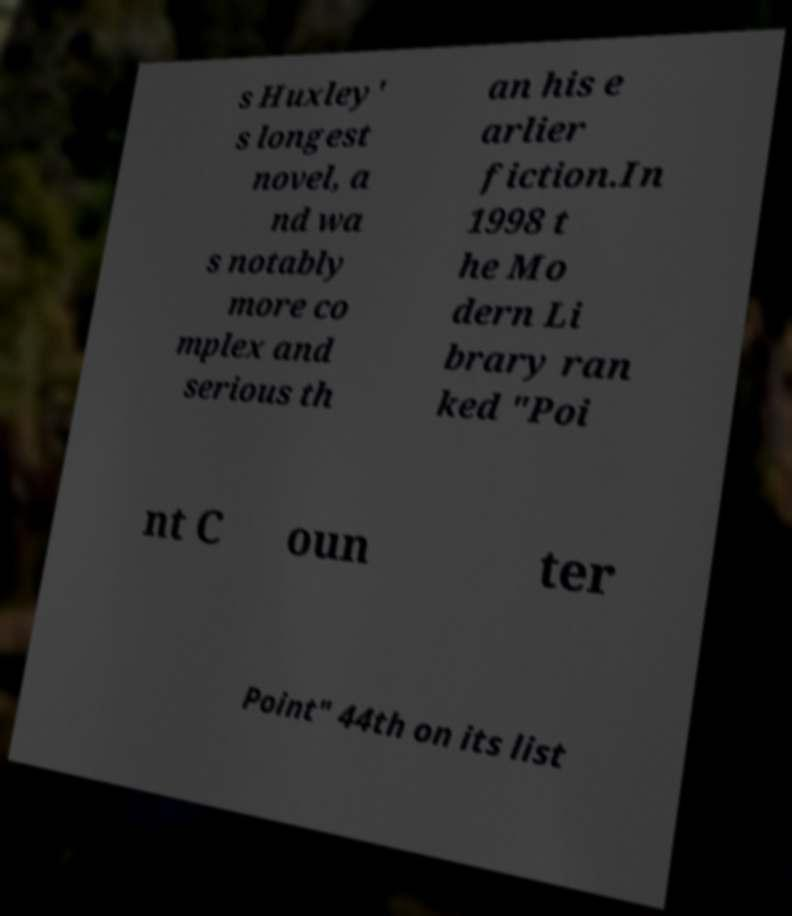Can you read and provide the text displayed in the image?This photo seems to have some interesting text. Can you extract and type it out for me? s Huxley' s longest novel, a nd wa s notably more co mplex and serious th an his e arlier fiction.In 1998 t he Mo dern Li brary ran ked "Poi nt C oun ter Point" 44th on its list 